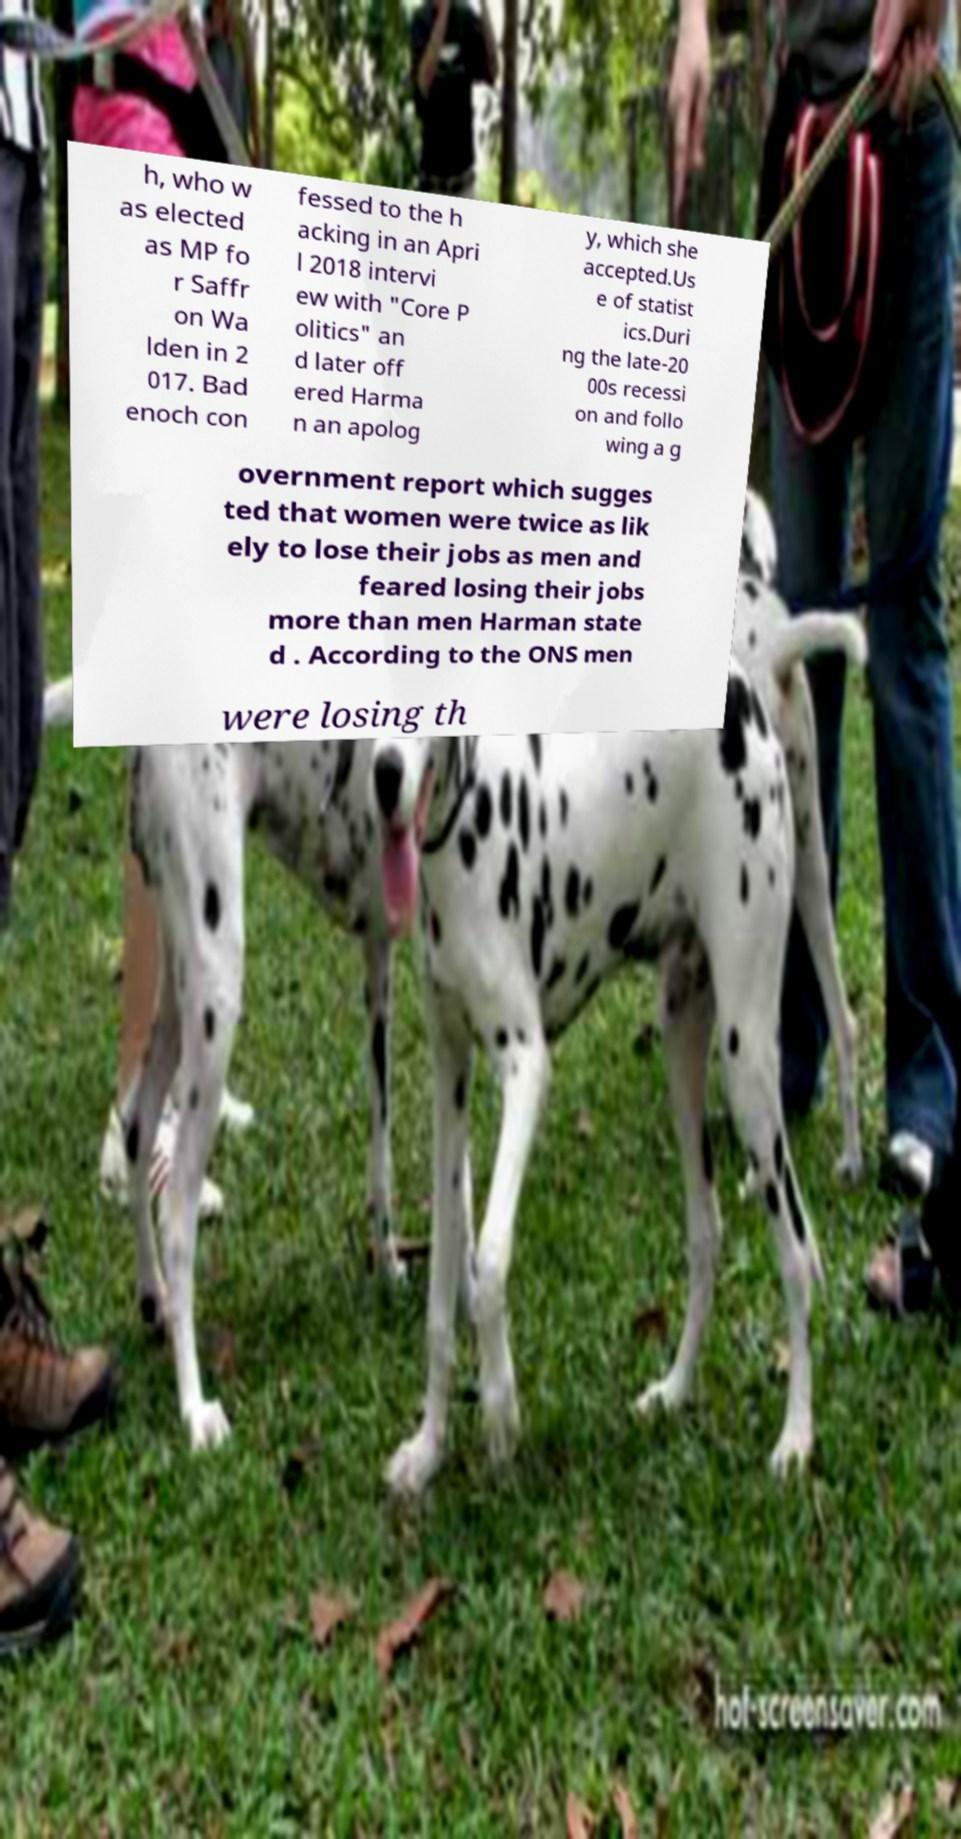What messages or text are displayed in this image? I need them in a readable, typed format. h, who w as elected as MP fo r Saffr on Wa lden in 2 017. Bad enoch con fessed to the h acking in an Apri l 2018 intervi ew with "Core P olitics" an d later off ered Harma n an apolog y, which she accepted.Us e of statist ics.Duri ng the late-20 00s recessi on and follo wing a g overnment report which sugges ted that women were twice as lik ely to lose their jobs as men and feared losing their jobs more than men Harman state d . According to the ONS men were losing th 